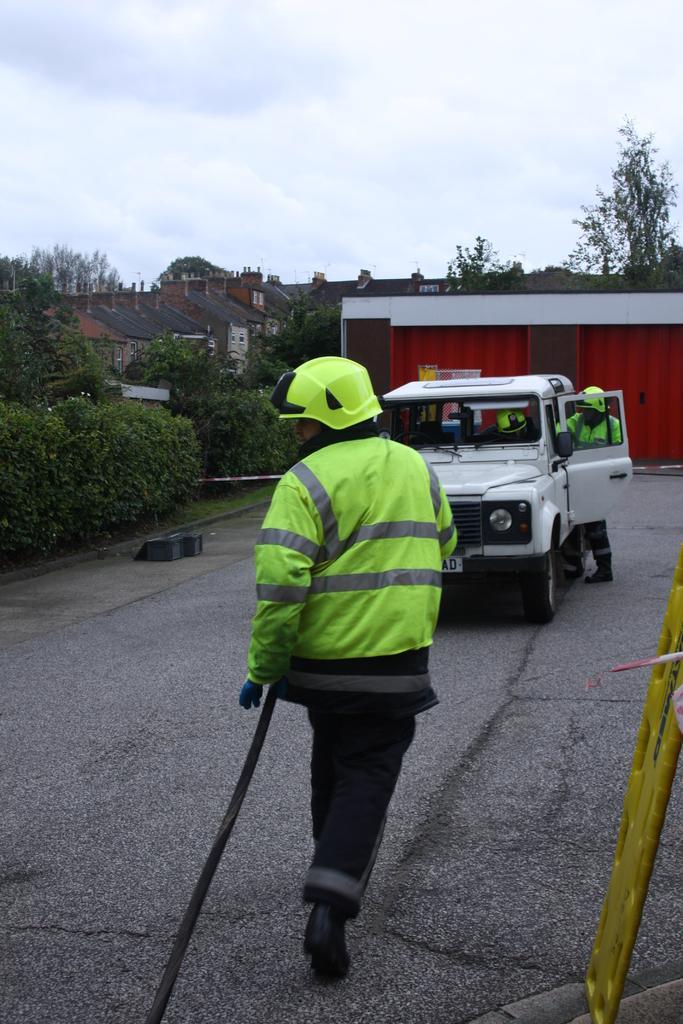Please provide a concise description of this image. There is a vehicle on the road. Here we can see three persons, plants, trees, and houses. In the background there is sky. 